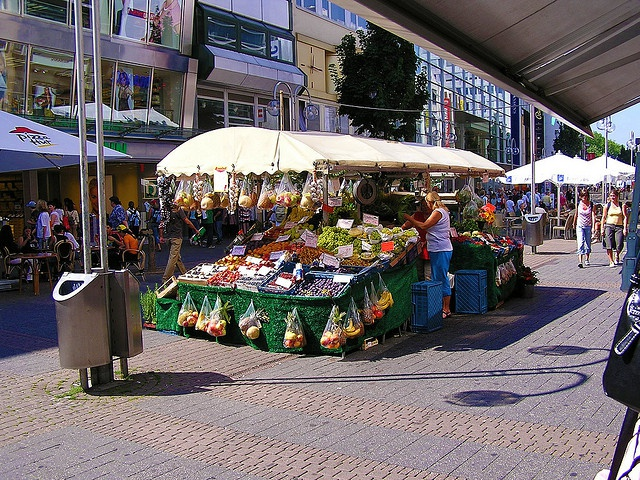Describe the objects in this image and their specific colors. I can see people in blue, black, gray, maroon, and darkgray tones, umbrella in blue, darkgray, navy, purple, and darkblue tones, handbag in blue, black, white, navy, and gray tones, people in blue, navy, maroon, black, and gray tones, and umbrella in blue, white, black, gray, and darkgray tones in this image. 